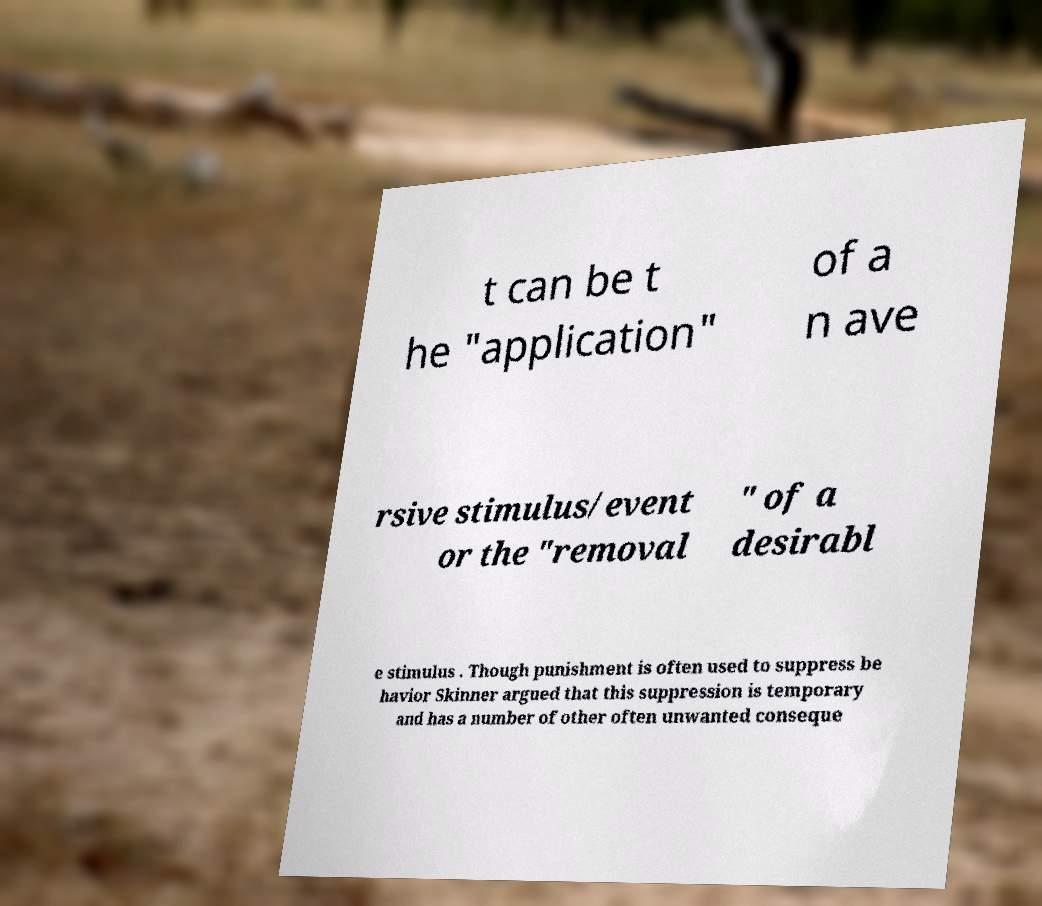For documentation purposes, I need the text within this image transcribed. Could you provide that? t can be t he "application" of a n ave rsive stimulus/event or the "removal " of a desirabl e stimulus . Though punishment is often used to suppress be havior Skinner argued that this suppression is temporary and has a number of other often unwanted conseque 